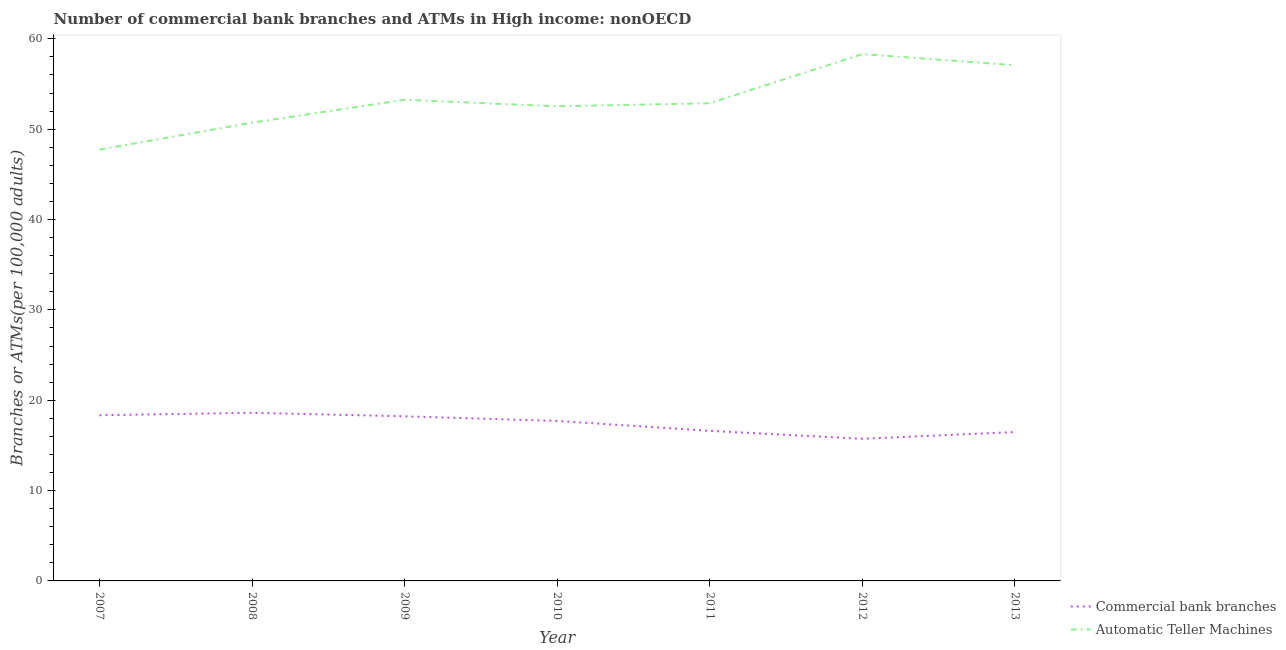Does the line corresponding to number of atms intersect with the line corresponding to number of commercal bank branches?
Keep it short and to the point. No. Is the number of lines equal to the number of legend labels?
Ensure brevity in your answer.  Yes. What is the number of atms in 2009?
Keep it short and to the point. 53.26. Across all years, what is the maximum number of commercal bank branches?
Keep it short and to the point. 18.61. Across all years, what is the minimum number of atms?
Your response must be concise. 47.74. In which year was the number of commercal bank branches minimum?
Keep it short and to the point. 2012. What is the total number of atms in the graph?
Provide a succinct answer. 372.52. What is the difference between the number of atms in 2007 and that in 2009?
Ensure brevity in your answer.  -5.52. What is the difference between the number of atms in 2013 and the number of commercal bank branches in 2008?
Give a very brief answer. 38.47. What is the average number of atms per year?
Your response must be concise. 53.22. In the year 2013, what is the difference between the number of atms and number of commercal bank branches?
Your answer should be compact. 40.6. In how many years, is the number of atms greater than 26?
Your answer should be very brief. 7. What is the ratio of the number of atms in 2009 to that in 2011?
Your answer should be compact. 1.01. Is the difference between the number of commercal bank branches in 2007 and 2010 greater than the difference between the number of atms in 2007 and 2010?
Ensure brevity in your answer.  Yes. What is the difference between the highest and the second highest number of commercal bank branches?
Your answer should be compact. 0.26. What is the difference between the highest and the lowest number of atms?
Keep it short and to the point. 10.57. In how many years, is the number of commercal bank branches greater than the average number of commercal bank branches taken over all years?
Your answer should be very brief. 4. Is the sum of the number of commercal bank branches in 2008 and 2010 greater than the maximum number of atms across all years?
Offer a very short reply. No. Does the number of atms monotonically increase over the years?
Ensure brevity in your answer.  No. Is the number of atms strictly less than the number of commercal bank branches over the years?
Your answer should be very brief. No. What is the difference between two consecutive major ticks on the Y-axis?
Your response must be concise. 10. Does the graph contain any zero values?
Provide a succinct answer. No. Where does the legend appear in the graph?
Offer a very short reply. Bottom right. What is the title of the graph?
Provide a short and direct response. Number of commercial bank branches and ATMs in High income: nonOECD. Does "Fraud firms" appear as one of the legend labels in the graph?
Provide a succinct answer. No. What is the label or title of the X-axis?
Provide a short and direct response. Year. What is the label or title of the Y-axis?
Your response must be concise. Branches or ATMs(per 100,0 adults). What is the Branches or ATMs(per 100,000 adults) in Commercial bank branches in 2007?
Provide a succinct answer. 18.34. What is the Branches or ATMs(per 100,000 adults) of Automatic Teller Machines in 2007?
Offer a terse response. 47.74. What is the Branches or ATMs(per 100,000 adults) in Commercial bank branches in 2008?
Offer a terse response. 18.61. What is the Branches or ATMs(per 100,000 adults) in Automatic Teller Machines in 2008?
Give a very brief answer. 50.72. What is the Branches or ATMs(per 100,000 adults) of Commercial bank branches in 2009?
Your response must be concise. 18.22. What is the Branches or ATMs(per 100,000 adults) in Automatic Teller Machines in 2009?
Keep it short and to the point. 53.26. What is the Branches or ATMs(per 100,000 adults) in Commercial bank branches in 2010?
Offer a very short reply. 17.71. What is the Branches or ATMs(per 100,000 adults) in Automatic Teller Machines in 2010?
Offer a very short reply. 52.53. What is the Branches or ATMs(per 100,000 adults) of Commercial bank branches in 2011?
Make the answer very short. 16.61. What is the Branches or ATMs(per 100,000 adults) of Automatic Teller Machines in 2011?
Offer a very short reply. 52.87. What is the Branches or ATMs(per 100,000 adults) of Commercial bank branches in 2012?
Your answer should be compact. 15.73. What is the Branches or ATMs(per 100,000 adults) of Automatic Teller Machines in 2012?
Give a very brief answer. 58.31. What is the Branches or ATMs(per 100,000 adults) of Commercial bank branches in 2013?
Offer a very short reply. 16.48. What is the Branches or ATMs(per 100,000 adults) in Automatic Teller Machines in 2013?
Ensure brevity in your answer.  57.08. Across all years, what is the maximum Branches or ATMs(per 100,000 adults) of Commercial bank branches?
Keep it short and to the point. 18.61. Across all years, what is the maximum Branches or ATMs(per 100,000 adults) of Automatic Teller Machines?
Your answer should be very brief. 58.31. Across all years, what is the minimum Branches or ATMs(per 100,000 adults) of Commercial bank branches?
Offer a terse response. 15.73. Across all years, what is the minimum Branches or ATMs(per 100,000 adults) of Automatic Teller Machines?
Keep it short and to the point. 47.74. What is the total Branches or ATMs(per 100,000 adults) in Commercial bank branches in the graph?
Provide a short and direct response. 121.7. What is the total Branches or ATMs(per 100,000 adults) in Automatic Teller Machines in the graph?
Offer a very short reply. 372.52. What is the difference between the Branches or ATMs(per 100,000 adults) in Commercial bank branches in 2007 and that in 2008?
Provide a short and direct response. -0.26. What is the difference between the Branches or ATMs(per 100,000 adults) of Automatic Teller Machines in 2007 and that in 2008?
Make the answer very short. -2.98. What is the difference between the Branches or ATMs(per 100,000 adults) in Commercial bank branches in 2007 and that in 2009?
Keep it short and to the point. 0.12. What is the difference between the Branches or ATMs(per 100,000 adults) in Automatic Teller Machines in 2007 and that in 2009?
Your answer should be very brief. -5.52. What is the difference between the Branches or ATMs(per 100,000 adults) in Commercial bank branches in 2007 and that in 2010?
Provide a short and direct response. 0.64. What is the difference between the Branches or ATMs(per 100,000 adults) of Automatic Teller Machines in 2007 and that in 2010?
Provide a short and direct response. -4.8. What is the difference between the Branches or ATMs(per 100,000 adults) of Commercial bank branches in 2007 and that in 2011?
Your response must be concise. 1.73. What is the difference between the Branches or ATMs(per 100,000 adults) in Automatic Teller Machines in 2007 and that in 2011?
Give a very brief answer. -5.14. What is the difference between the Branches or ATMs(per 100,000 adults) of Commercial bank branches in 2007 and that in 2012?
Provide a succinct answer. 2.61. What is the difference between the Branches or ATMs(per 100,000 adults) in Automatic Teller Machines in 2007 and that in 2012?
Your response must be concise. -10.57. What is the difference between the Branches or ATMs(per 100,000 adults) in Commercial bank branches in 2007 and that in 2013?
Give a very brief answer. 1.86. What is the difference between the Branches or ATMs(per 100,000 adults) in Automatic Teller Machines in 2007 and that in 2013?
Ensure brevity in your answer.  -9.34. What is the difference between the Branches or ATMs(per 100,000 adults) in Commercial bank branches in 2008 and that in 2009?
Provide a short and direct response. 0.39. What is the difference between the Branches or ATMs(per 100,000 adults) of Automatic Teller Machines in 2008 and that in 2009?
Offer a terse response. -2.53. What is the difference between the Branches or ATMs(per 100,000 adults) in Commercial bank branches in 2008 and that in 2010?
Provide a short and direct response. 0.9. What is the difference between the Branches or ATMs(per 100,000 adults) of Automatic Teller Machines in 2008 and that in 2010?
Your answer should be very brief. -1.81. What is the difference between the Branches or ATMs(per 100,000 adults) in Commercial bank branches in 2008 and that in 2011?
Your answer should be very brief. 2. What is the difference between the Branches or ATMs(per 100,000 adults) of Automatic Teller Machines in 2008 and that in 2011?
Your answer should be very brief. -2.15. What is the difference between the Branches or ATMs(per 100,000 adults) of Commercial bank branches in 2008 and that in 2012?
Provide a succinct answer. 2.88. What is the difference between the Branches or ATMs(per 100,000 adults) in Automatic Teller Machines in 2008 and that in 2012?
Keep it short and to the point. -7.59. What is the difference between the Branches or ATMs(per 100,000 adults) in Commercial bank branches in 2008 and that in 2013?
Your response must be concise. 2.13. What is the difference between the Branches or ATMs(per 100,000 adults) in Automatic Teller Machines in 2008 and that in 2013?
Offer a terse response. -6.36. What is the difference between the Branches or ATMs(per 100,000 adults) of Commercial bank branches in 2009 and that in 2010?
Your response must be concise. 0.51. What is the difference between the Branches or ATMs(per 100,000 adults) of Automatic Teller Machines in 2009 and that in 2010?
Your answer should be compact. 0.72. What is the difference between the Branches or ATMs(per 100,000 adults) of Commercial bank branches in 2009 and that in 2011?
Give a very brief answer. 1.61. What is the difference between the Branches or ATMs(per 100,000 adults) of Automatic Teller Machines in 2009 and that in 2011?
Your response must be concise. 0.38. What is the difference between the Branches or ATMs(per 100,000 adults) in Commercial bank branches in 2009 and that in 2012?
Make the answer very short. 2.49. What is the difference between the Branches or ATMs(per 100,000 adults) in Automatic Teller Machines in 2009 and that in 2012?
Your answer should be compact. -5.05. What is the difference between the Branches or ATMs(per 100,000 adults) in Commercial bank branches in 2009 and that in 2013?
Keep it short and to the point. 1.74. What is the difference between the Branches or ATMs(per 100,000 adults) of Automatic Teller Machines in 2009 and that in 2013?
Ensure brevity in your answer.  -3.83. What is the difference between the Branches or ATMs(per 100,000 adults) of Commercial bank branches in 2010 and that in 2011?
Give a very brief answer. 1.1. What is the difference between the Branches or ATMs(per 100,000 adults) of Automatic Teller Machines in 2010 and that in 2011?
Your response must be concise. -0.34. What is the difference between the Branches or ATMs(per 100,000 adults) in Commercial bank branches in 2010 and that in 2012?
Provide a short and direct response. 1.98. What is the difference between the Branches or ATMs(per 100,000 adults) of Automatic Teller Machines in 2010 and that in 2012?
Keep it short and to the point. -5.78. What is the difference between the Branches or ATMs(per 100,000 adults) in Commercial bank branches in 2010 and that in 2013?
Make the answer very short. 1.22. What is the difference between the Branches or ATMs(per 100,000 adults) of Automatic Teller Machines in 2010 and that in 2013?
Make the answer very short. -4.55. What is the difference between the Branches or ATMs(per 100,000 adults) in Commercial bank branches in 2011 and that in 2012?
Your response must be concise. 0.88. What is the difference between the Branches or ATMs(per 100,000 adults) in Automatic Teller Machines in 2011 and that in 2012?
Your answer should be very brief. -5.44. What is the difference between the Branches or ATMs(per 100,000 adults) of Commercial bank branches in 2011 and that in 2013?
Your answer should be compact. 0.13. What is the difference between the Branches or ATMs(per 100,000 adults) in Automatic Teller Machines in 2011 and that in 2013?
Offer a terse response. -4.21. What is the difference between the Branches or ATMs(per 100,000 adults) in Commercial bank branches in 2012 and that in 2013?
Keep it short and to the point. -0.75. What is the difference between the Branches or ATMs(per 100,000 adults) in Automatic Teller Machines in 2012 and that in 2013?
Offer a very short reply. 1.23. What is the difference between the Branches or ATMs(per 100,000 adults) of Commercial bank branches in 2007 and the Branches or ATMs(per 100,000 adults) of Automatic Teller Machines in 2008?
Your response must be concise. -32.38. What is the difference between the Branches or ATMs(per 100,000 adults) of Commercial bank branches in 2007 and the Branches or ATMs(per 100,000 adults) of Automatic Teller Machines in 2009?
Make the answer very short. -34.91. What is the difference between the Branches or ATMs(per 100,000 adults) in Commercial bank branches in 2007 and the Branches or ATMs(per 100,000 adults) in Automatic Teller Machines in 2010?
Your answer should be compact. -34.19. What is the difference between the Branches or ATMs(per 100,000 adults) in Commercial bank branches in 2007 and the Branches or ATMs(per 100,000 adults) in Automatic Teller Machines in 2011?
Your response must be concise. -34.53. What is the difference between the Branches or ATMs(per 100,000 adults) of Commercial bank branches in 2007 and the Branches or ATMs(per 100,000 adults) of Automatic Teller Machines in 2012?
Your answer should be compact. -39.97. What is the difference between the Branches or ATMs(per 100,000 adults) of Commercial bank branches in 2007 and the Branches or ATMs(per 100,000 adults) of Automatic Teller Machines in 2013?
Offer a terse response. -38.74. What is the difference between the Branches or ATMs(per 100,000 adults) in Commercial bank branches in 2008 and the Branches or ATMs(per 100,000 adults) in Automatic Teller Machines in 2009?
Make the answer very short. -34.65. What is the difference between the Branches or ATMs(per 100,000 adults) in Commercial bank branches in 2008 and the Branches or ATMs(per 100,000 adults) in Automatic Teller Machines in 2010?
Provide a succinct answer. -33.93. What is the difference between the Branches or ATMs(per 100,000 adults) in Commercial bank branches in 2008 and the Branches or ATMs(per 100,000 adults) in Automatic Teller Machines in 2011?
Your response must be concise. -34.27. What is the difference between the Branches or ATMs(per 100,000 adults) in Commercial bank branches in 2008 and the Branches or ATMs(per 100,000 adults) in Automatic Teller Machines in 2012?
Provide a short and direct response. -39.7. What is the difference between the Branches or ATMs(per 100,000 adults) of Commercial bank branches in 2008 and the Branches or ATMs(per 100,000 adults) of Automatic Teller Machines in 2013?
Offer a very short reply. -38.48. What is the difference between the Branches or ATMs(per 100,000 adults) of Commercial bank branches in 2009 and the Branches or ATMs(per 100,000 adults) of Automatic Teller Machines in 2010?
Offer a terse response. -34.31. What is the difference between the Branches or ATMs(per 100,000 adults) of Commercial bank branches in 2009 and the Branches or ATMs(per 100,000 adults) of Automatic Teller Machines in 2011?
Make the answer very short. -34.65. What is the difference between the Branches or ATMs(per 100,000 adults) of Commercial bank branches in 2009 and the Branches or ATMs(per 100,000 adults) of Automatic Teller Machines in 2012?
Your response must be concise. -40.09. What is the difference between the Branches or ATMs(per 100,000 adults) in Commercial bank branches in 2009 and the Branches or ATMs(per 100,000 adults) in Automatic Teller Machines in 2013?
Provide a short and direct response. -38.86. What is the difference between the Branches or ATMs(per 100,000 adults) in Commercial bank branches in 2010 and the Branches or ATMs(per 100,000 adults) in Automatic Teller Machines in 2011?
Ensure brevity in your answer.  -35.17. What is the difference between the Branches or ATMs(per 100,000 adults) of Commercial bank branches in 2010 and the Branches or ATMs(per 100,000 adults) of Automatic Teller Machines in 2012?
Ensure brevity in your answer.  -40.6. What is the difference between the Branches or ATMs(per 100,000 adults) of Commercial bank branches in 2010 and the Branches or ATMs(per 100,000 adults) of Automatic Teller Machines in 2013?
Keep it short and to the point. -39.38. What is the difference between the Branches or ATMs(per 100,000 adults) in Commercial bank branches in 2011 and the Branches or ATMs(per 100,000 adults) in Automatic Teller Machines in 2012?
Offer a very short reply. -41.7. What is the difference between the Branches or ATMs(per 100,000 adults) in Commercial bank branches in 2011 and the Branches or ATMs(per 100,000 adults) in Automatic Teller Machines in 2013?
Offer a very short reply. -40.47. What is the difference between the Branches or ATMs(per 100,000 adults) in Commercial bank branches in 2012 and the Branches or ATMs(per 100,000 adults) in Automatic Teller Machines in 2013?
Provide a succinct answer. -41.35. What is the average Branches or ATMs(per 100,000 adults) of Commercial bank branches per year?
Offer a terse response. 17.39. What is the average Branches or ATMs(per 100,000 adults) of Automatic Teller Machines per year?
Your response must be concise. 53.22. In the year 2007, what is the difference between the Branches or ATMs(per 100,000 adults) in Commercial bank branches and Branches or ATMs(per 100,000 adults) in Automatic Teller Machines?
Your response must be concise. -29.4. In the year 2008, what is the difference between the Branches or ATMs(per 100,000 adults) of Commercial bank branches and Branches or ATMs(per 100,000 adults) of Automatic Teller Machines?
Make the answer very short. -32.11. In the year 2009, what is the difference between the Branches or ATMs(per 100,000 adults) of Commercial bank branches and Branches or ATMs(per 100,000 adults) of Automatic Teller Machines?
Provide a succinct answer. -35.04. In the year 2010, what is the difference between the Branches or ATMs(per 100,000 adults) in Commercial bank branches and Branches or ATMs(per 100,000 adults) in Automatic Teller Machines?
Provide a succinct answer. -34.83. In the year 2011, what is the difference between the Branches or ATMs(per 100,000 adults) in Commercial bank branches and Branches or ATMs(per 100,000 adults) in Automatic Teller Machines?
Give a very brief answer. -36.26. In the year 2012, what is the difference between the Branches or ATMs(per 100,000 adults) in Commercial bank branches and Branches or ATMs(per 100,000 adults) in Automatic Teller Machines?
Give a very brief answer. -42.58. In the year 2013, what is the difference between the Branches or ATMs(per 100,000 adults) of Commercial bank branches and Branches or ATMs(per 100,000 adults) of Automatic Teller Machines?
Keep it short and to the point. -40.6. What is the ratio of the Branches or ATMs(per 100,000 adults) of Commercial bank branches in 2007 to that in 2008?
Make the answer very short. 0.99. What is the ratio of the Branches or ATMs(per 100,000 adults) of Automatic Teller Machines in 2007 to that in 2009?
Your answer should be compact. 0.9. What is the ratio of the Branches or ATMs(per 100,000 adults) of Commercial bank branches in 2007 to that in 2010?
Keep it short and to the point. 1.04. What is the ratio of the Branches or ATMs(per 100,000 adults) of Automatic Teller Machines in 2007 to that in 2010?
Give a very brief answer. 0.91. What is the ratio of the Branches or ATMs(per 100,000 adults) of Commercial bank branches in 2007 to that in 2011?
Provide a short and direct response. 1.1. What is the ratio of the Branches or ATMs(per 100,000 adults) in Automatic Teller Machines in 2007 to that in 2011?
Your answer should be very brief. 0.9. What is the ratio of the Branches or ATMs(per 100,000 adults) of Commercial bank branches in 2007 to that in 2012?
Your response must be concise. 1.17. What is the ratio of the Branches or ATMs(per 100,000 adults) in Automatic Teller Machines in 2007 to that in 2012?
Your response must be concise. 0.82. What is the ratio of the Branches or ATMs(per 100,000 adults) of Commercial bank branches in 2007 to that in 2013?
Your answer should be compact. 1.11. What is the ratio of the Branches or ATMs(per 100,000 adults) of Automatic Teller Machines in 2007 to that in 2013?
Provide a short and direct response. 0.84. What is the ratio of the Branches or ATMs(per 100,000 adults) in Commercial bank branches in 2008 to that in 2009?
Keep it short and to the point. 1.02. What is the ratio of the Branches or ATMs(per 100,000 adults) in Automatic Teller Machines in 2008 to that in 2009?
Keep it short and to the point. 0.95. What is the ratio of the Branches or ATMs(per 100,000 adults) of Commercial bank branches in 2008 to that in 2010?
Your answer should be compact. 1.05. What is the ratio of the Branches or ATMs(per 100,000 adults) in Automatic Teller Machines in 2008 to that in 2010?
Offer a terse response. 0.97. What is the ratio of the Branches or ATMs(per 100,000 adults) of Commercial bank branches in 2008 to that in 2011?
Ensure brevity in your answer.  1.12. What is the ratio of the Branches or ATMs(per 100,000 adults) of Automatic Teller Machines in 2008 to that in 2011?
Provide a short and direct response. 0.96. What is the ratio of the Branches or ATMs(per 100,000 adults) of Commercial bank branches in 2008 to that in 2012?
Provide a short and direct response. 1.18. What is the ratio of the Branches or ATMs(per 100,000 adults) in Automatic Teller Machines in 2008 to that in 2012?
Your response must be concise. 0.87. What is the ratio of the Branches or ATMs(per 100,000 adults) of Commercial bank branches in 2008 to that in 2013?
Your response must be concise. 1.13. What is the ratio of the Branches or ATMs(per 100,000 adults) in Automatic Teller Machines in 2008 to that in 2013?
Make the answer very short. 0.89. What is the ratio of the Branches or ATMs(per 100,000 adults) in Commercial bank branches in 2009 to that in 2010?
Offer a terse response. 1.03. What is the ratio of the Branches or ATMs(per 100,000 adults) of Automatic Teller Machines in 2009 to that in 2010?
Give a very brief answer. 1.01. What is the ratio of the Branches or ATMs(per 100,000 adults) in Commercial bank branches in 2009 to that in 2011?
Keep it short and to the point. 1.1. What is the ratio of the Branches or ATMs(per 100,000 adults) of Commercial bank branches in 2009 to that in 2012?
Offer a very short reply. 1.16. What is the ratio of the Branches or ATMs(per 100,000 adults) of Automatic Teller Machines in 2009 to that in 2012?
Your answer should be very brief. 0.91. What is the ratio of the Branches or ATMs(per 100,000 adults) in Commercial bank branches in 2009 to that in 2013?
Your response must be concise. 1.11. What is the ratio of the Branches or ATMs(per 100,000 adults) of Automatic Teller Machines in 2009 to that in 2013?
Make the answer very short. 0.93. What is the ratio of the Branches or ATMs(per 100,000 adults) of Commercial bank branches in 2010 to that in 2011?
Your response must be concise. 1.07. What is the ratio of the Branches or ATMs(per 100,000 adults) of Commercial bank branches in 2010 to that in 2012?
Keep it short and to the point. 1.13. What is the ratio of the Branches or ATMs(per 100,000 adults) of Automatic Teller Machines in 2010 to that in 2012?
Give a very brief answer. 0.9. What is the ratio of the Branches or ATMs(per 100,000 adults) of Commercial bank branches in 2010 to that in 2013?
Your response must be concise. 1.07. What is the ratio of the Branches or ATMs(per 100,000 adults) in Automatic Teller Machines in 2010 to that in 2013?
Make the answer very short. 0.92. What is the ratio of the Branches or ATMs(per 100,000 adults) in Commercial bank branches in 2011 to that in 2012?
Offer a very short reply. 1.06. What is the ratio of the Branches or ATMs(per 100,000 adults) of Automatic Teller Machines in 2011 to that in 2012?
Offer a very short reply. 0.91. What is the ratio of the Branches or ATMs(per 100,000 adults) of Commercial bank branches in 2011 to that in 2013?
Give a very brief answer. 1.01. What is the ratio of the Branches or ATMs(per 100,000 adults) of Automatic Teller Machines in 2011 to that in 2013?
Provide a short and direct response. 0.93. What is the ratio of the Branches or ATMs(per 100,000 adults) of Commercial bank branches in 2012 to that in 2013?
Your answer should be compact. 0.95. What is the ratio of the Branches or ATMs(per 100,000 adults) of Automatic Teller Machines in 2012 to that in 2013?
Offer a very short reply. 1.02. What is the difference between the highest and the second highest Branches or ATMs(per 100,000 adults) in Commercial bank branches?
Your answer should be compact. 0.26. What is the difference between the highest and the second highest Branches or ATMs(per 100,000 adults) of Automatic Teller Machines?
Provide a short and direct response. 1.23. What is the difference between the highest and the lowest Branches or ATMs(per 100,000 adults) in Commercial bank branches?
Provide a short and direct response. 2.88. What is the difference between the highest and the lowest Branches or ATMs(per 100,000 adults) of Automatic Teller Machines?
Your answer should be very brief. 10.57. 